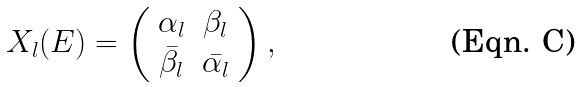Convert formula to latex. <formula><loc_0><loc_0><loc_500><loc_500>X _ { l } ( E ) = \left ( \begin{array} { c c } \alpha _ { l } & \beta _ { l } \\ \bar { \beta _ { l } } & \bar { \alpha _ { l } } \end{array} \right ) ,</formula> 